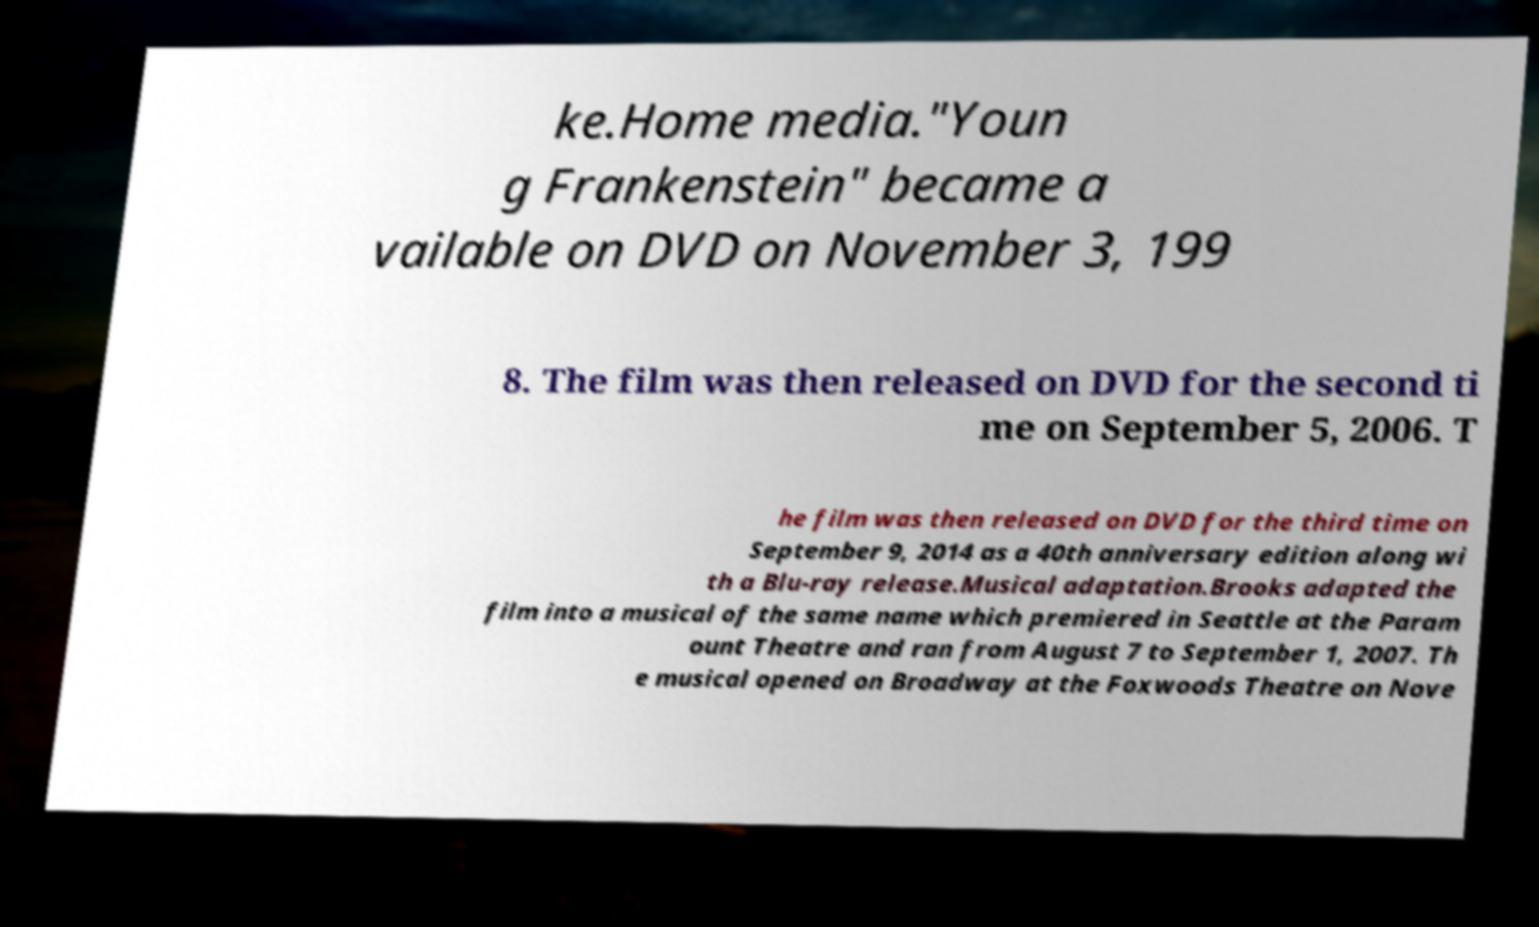Please read and relay the text visible in this image. What does it say? ke.Home media."Youn g Frankenstein" became a vailable on DVD on November 3, 199 8. The film was then released on DVD for the second ti me on September 5, 2006. T he film was then released on DVD for the third time on September 9, 2014 as a 40th anniversary edition along wi th a Blu-ray release.Musical adaptation.Brooks adapted the film into a musical of the same name which premiered in Seattle at the Param ount Theatre and ran from August 7 to September 1, 2007. Th e musical opened on Broadway at the Foxwoods Theatre on Nove 